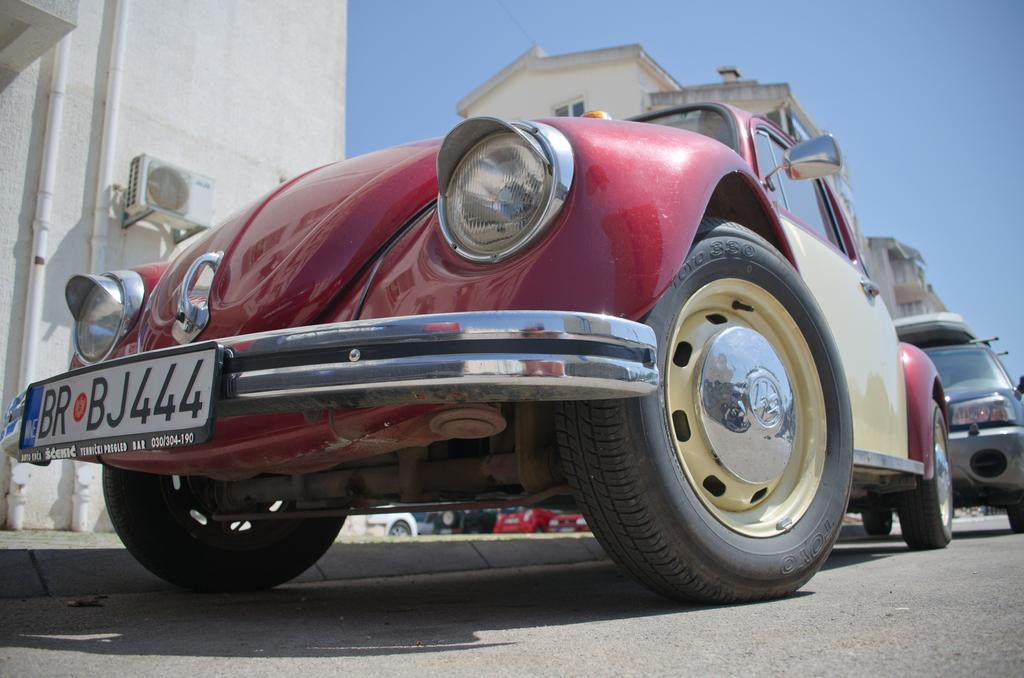What can be seen on the road in the image? There are cars parked on the road in the image. What is visible in the distance behind the parked cars? There are buildings visible in the background of the image. What else can be seen in the background of the image? The sky is visible in the background of the image. Can you hear the coach laughing in the image? There is no coach or laughter present in the image; it only shows parked cars, buildings, and the sky. 